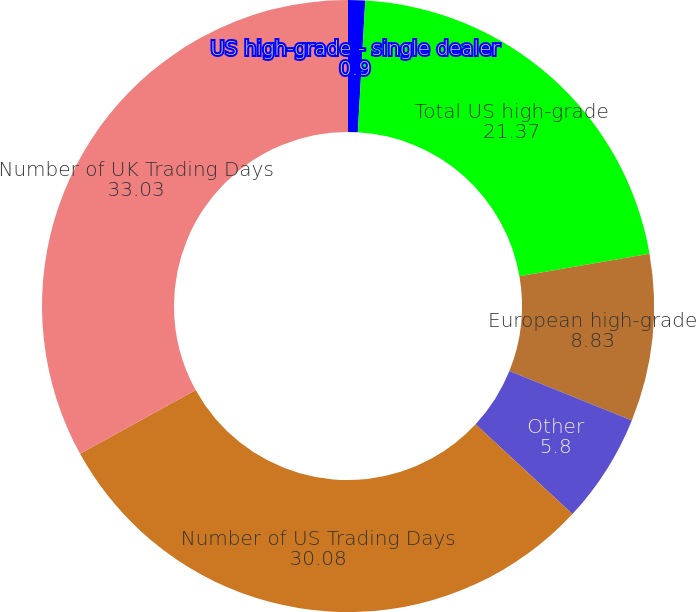Convert chart. <chart><loc_0><loc_0><loc_500><loc_500><pie_chart><fcel>US high-grade - single dealer<fcel>Total US high-grade<fcel>European high-grade<fcel>Other<fcel>Number of US Trading Days<fcel>Number of UK Trading Days<nl><fcel>0.9%<fcel>21.37%<fcel>8.83%<fcel>5.8%<fcel>30.08%<fcel>33.03%<nl></chart> 